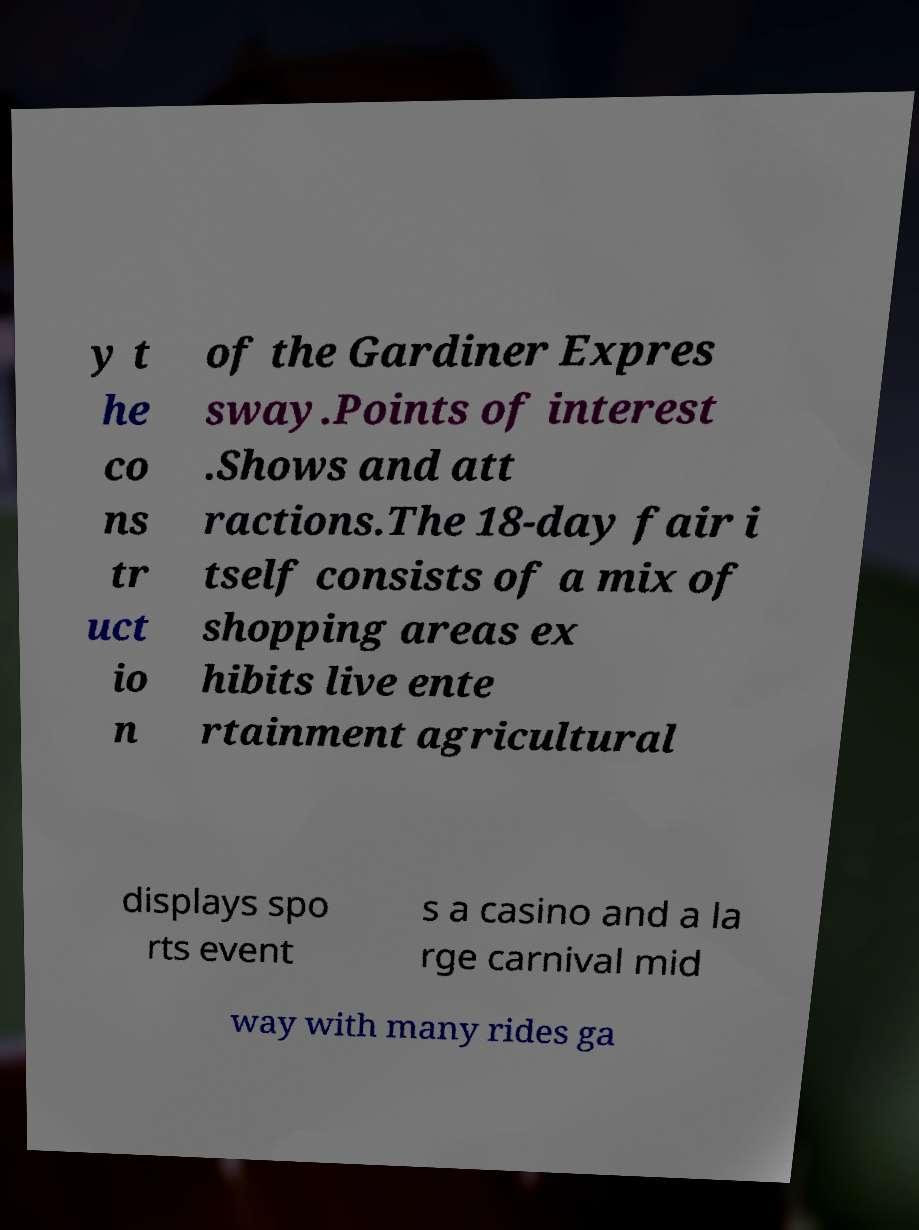I need the written content from this picture converted into text. Can you do that? y t he co ns tr uct io n of the Gardiner Expres sway.Points of interest .Shows and att ractions.The 18-day fair i tself consists of a mix of shopping areas ex hibits live ente rtainment agricultural displays spo rts event s a casino and a la rge carnival mid way with many rides ga 